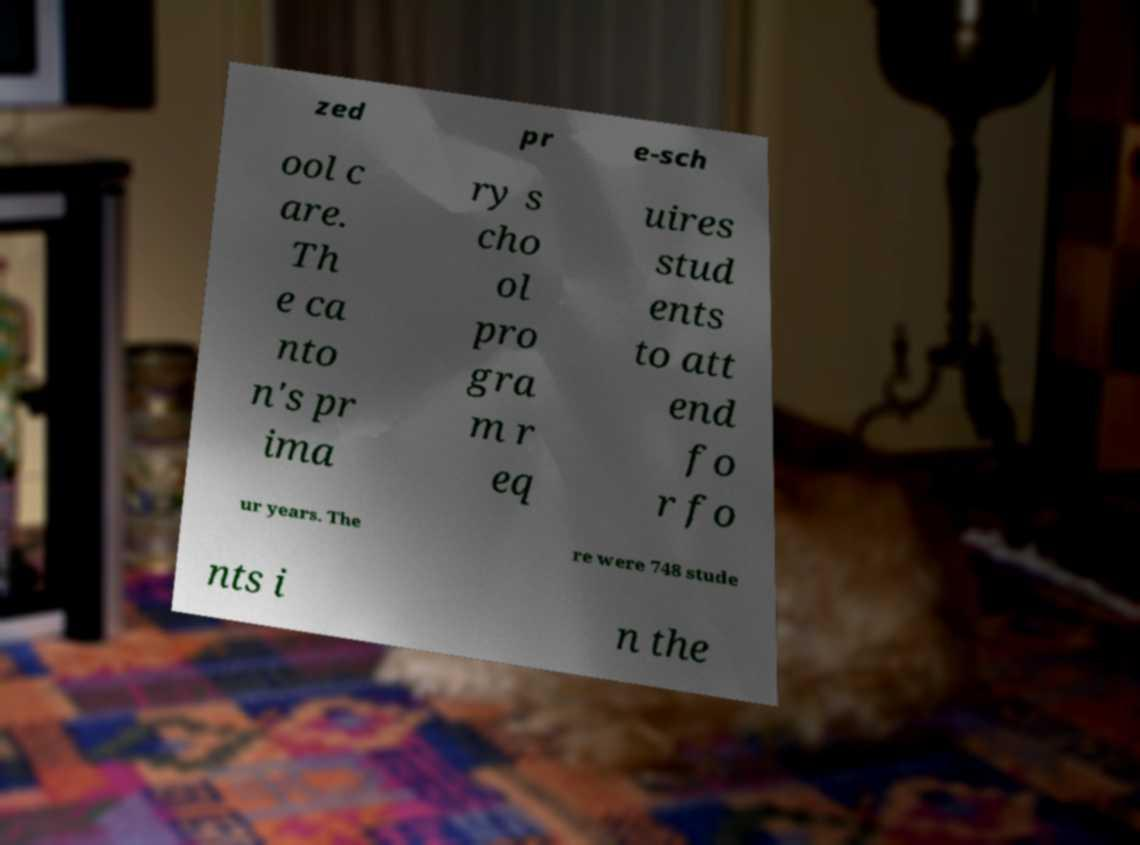Can you read and provide the text displayed in the image?This photo seems to have some interesting text. Can you extract and type it out for me? zed pr e-sch ool c are. Th e ca nto n's pr ima ry s cho ol pro gra m r eq uires stud ents to att end fo r fo ur years. The re were 748 stude nts i n the 